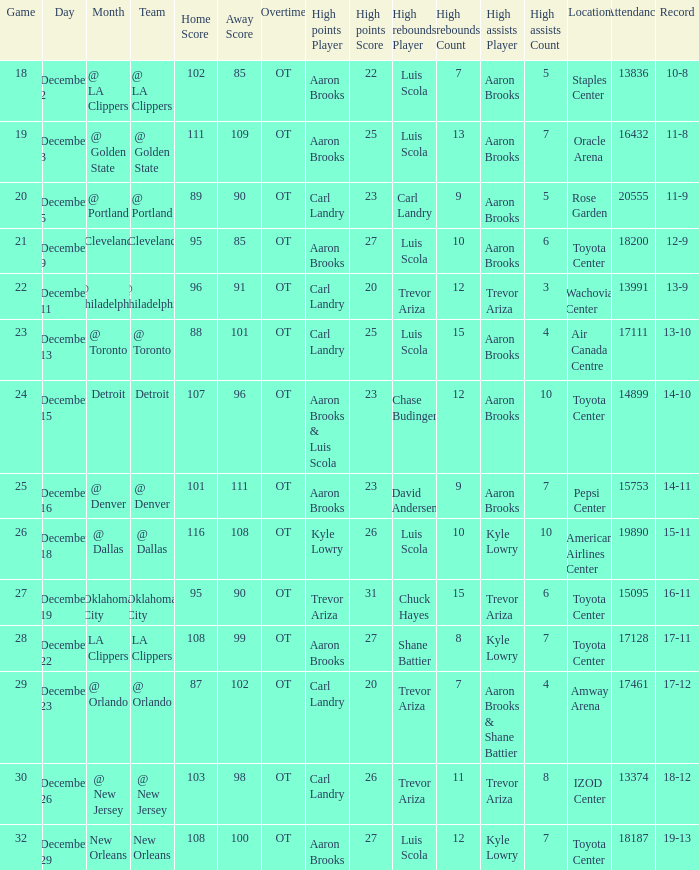Who grabbed the maximum rebounds in the contest where carl landry (23) accumulated the highest points? Carl Landry (9). 